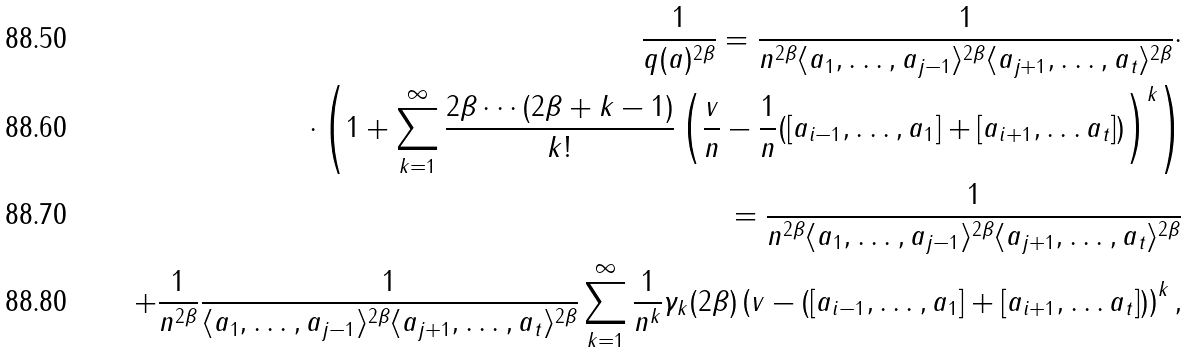Convert formula to latex. <formula><loc_0><loc_0><loc_500><loc_500>\frac { 1 } { q ( a ) ^ { 2 \beta } } = \frac { 1 } { n ^ { 2 \beta } \langle a _ { 1 } , \dots , a _ { j - 1 } \rangle ^ { 2 \beta } \langle a _ { j + 1 } , \dots , a _ { t } \rangle ^ { 2 \beta } } \cdot \\ \cdot \left ( 1 + \sum _ { k = 1 } ^ { \infty } \frac { 2 \beta \cdots \left ( 2 \beta + k - 1 \right ) } { k ! } \left ( \frac { v } { n } - \frac { 1 } { n } ( [ a _ { i - 1 } , \dots , a _ { 1 } ] + [ a _ { i + 1 } , \dots a _ { t } ] ) \right ) ^ { k } \right ) \\ = \frac { 1 } { n ^ { 2 \beta } \langle a _ { 1 } , \dots , a _ { j - 1 } \rangle ^ { 2 \beta } \langle a _ { j + 1 } , \dots , a _ { t } \rangle ^ { 2 \beta } } \\ + \frac { 1 } { n ^ { 2 \beta } } \frac { 1 } { \langle a _ { 1 } , \dots , a _ { j - 1 } \rangle ^ { 2 \beta } \langle a _ { j + 1 } , \dots , a _ { t } \rangle ^ { 2 \beta } } \sum _ { k = 1 } ^ { \infty } \frac { 1 } { n ^ { k } } \gamma _ { k } ( 2 \beta ) \left ( v - ( [ a _ { i - 1 } , \dots , a _ { 1 } ] + [ a _ { i + 1 } , \dots a _ { t } ] ) \right ) ^ { k } ,</formula> 